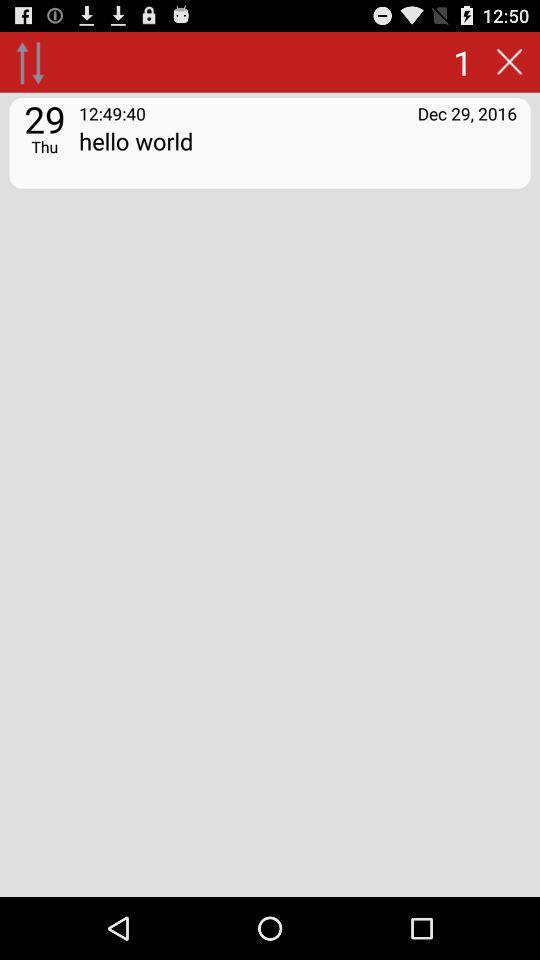What is the date on the screen? The date on the screen is Thursday, December 29, 2016. 